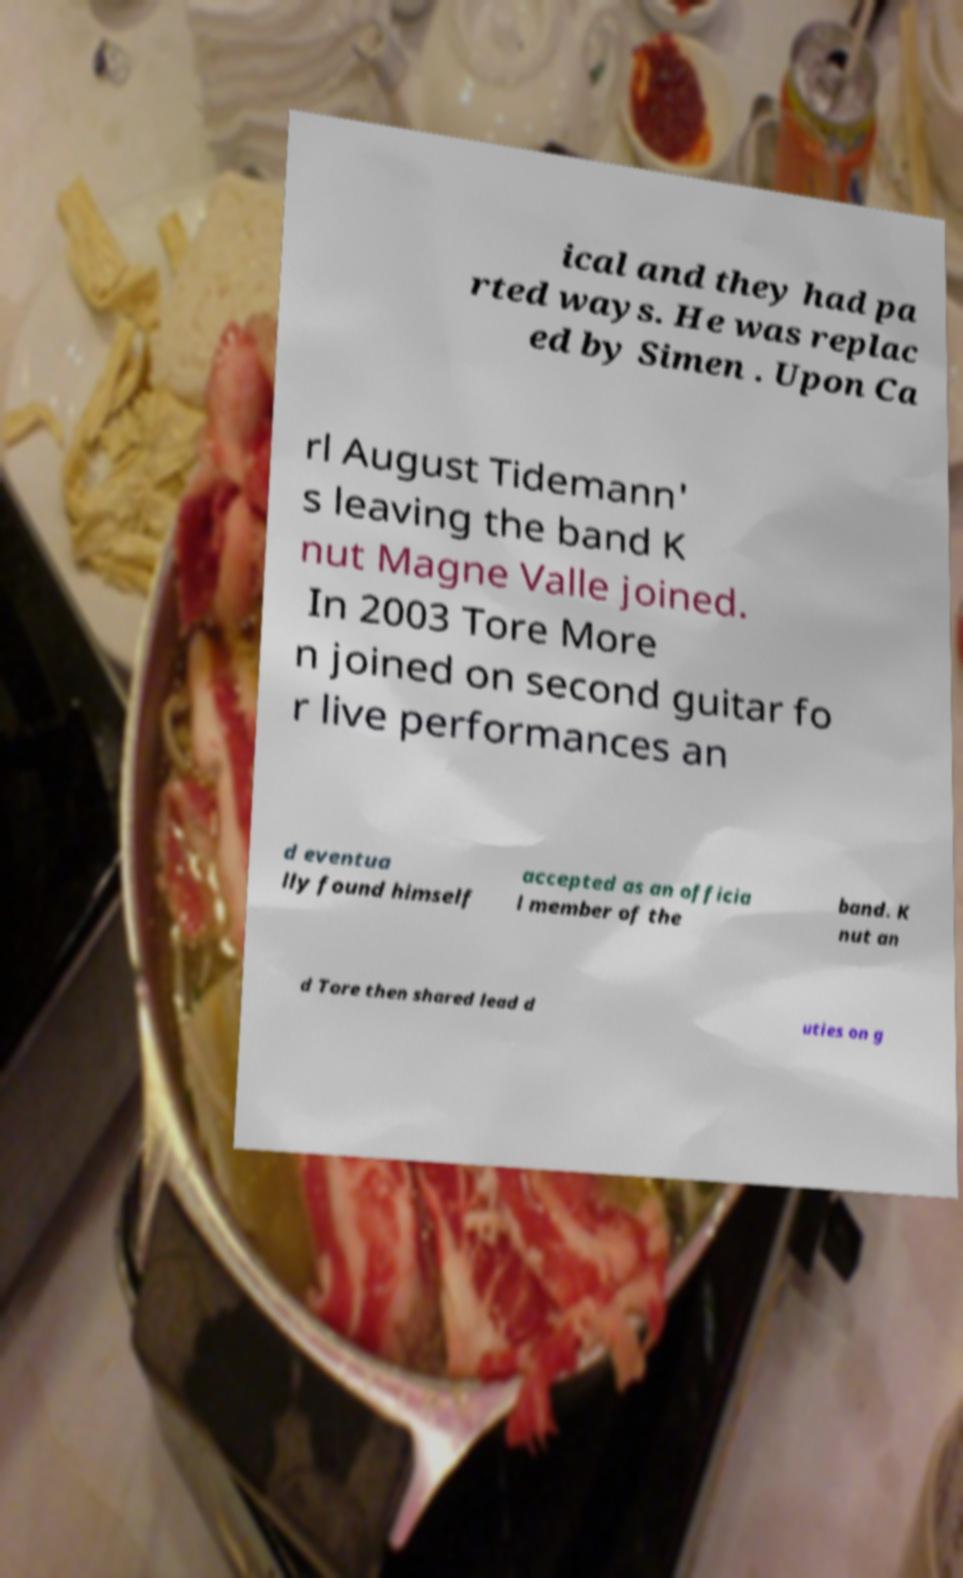Could you assist in decoding the text presented in this image and type it out clearly? ical and they had pa rted ways. He was replac ed by Simen . Upon Ca rl August Tidemann' s leaving the band K nut Magne Valle joined. In 2003 Tore More n joined on second guitar fo r live performances an d eventua lly found himself accepted as an officia l member of the band. K nut an d Tore then shared lead d uties on g 